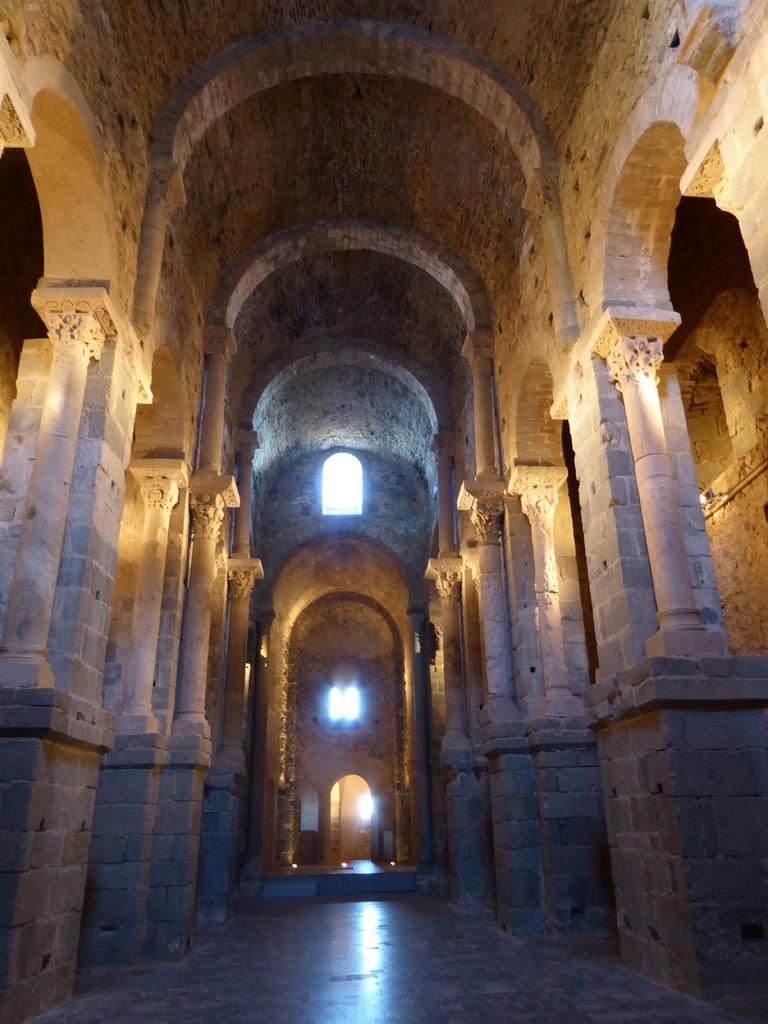What architectural features can be seen on the sides of the image? There are pillars on both the left and right sides of the image. What other structural elements are visible in the image? There are walls visible in the image. What can be seen in the walls of the image? Windows are present in the image. What is visible at the top of the image? The roof is visible at the top of the image. What type of table is used to connect the pillars in the image? There is no table present in the image, and the pillars are not connected by any visible means. 